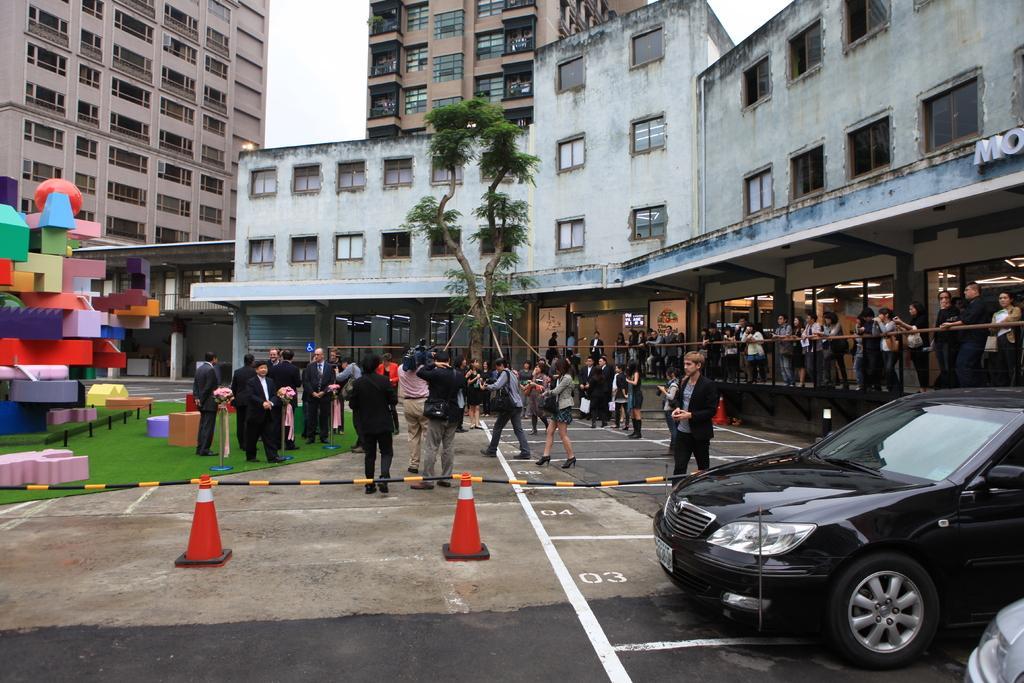Could you give a brief overview of what you see in this image? In this image we can see many people. There are few buildings in the image. There is a grassy land in the image. There is a sky in the image. There is a road safety cones in the image. There is a road in the image. There is a tree in the image. 